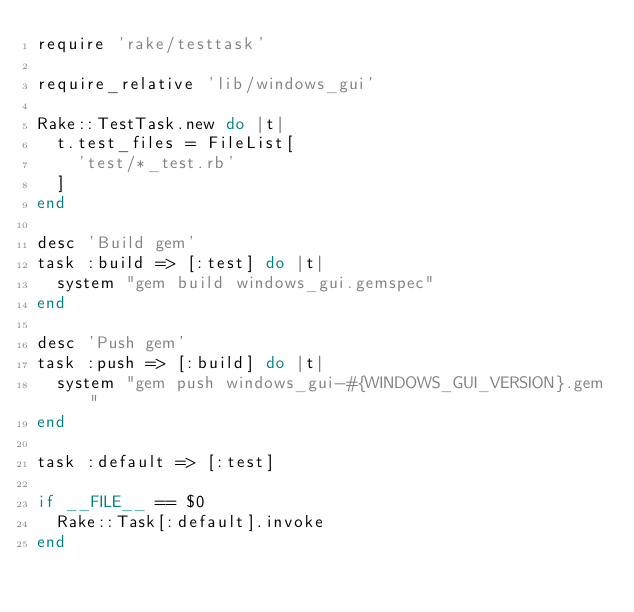<code> <loc_0><loc_0><loc_500><loc_500><_Ruby_>require 'rake/testtask'

require_relative 'lib/windows_gui'

Rake::TestTask.new do |t|
  t.test_files = FileList[
    'test/*_test.rb'
  ]
end

desc 'Build gem'
task :build => [:test] do |t|
  system "gem build windows_gui.gemspec"
end

desc 'Push gem'
task :push => [:build] do |t|
  system "gem push windows_gui-#{WINDOWS_GUI_VERSION}.gem"
end

task :default => [:test]

if __FILE__ == $0
  Rake::Task[:default].invoke
end
</code> 